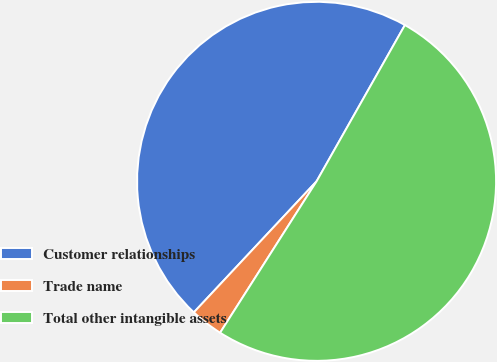Convert chart to OTSL. <chart><loc_0><loc_0><loc_500><loc_500><pie_chart><fcel>Customer relationships<fcel>Trade name<fcel>Total other intangible assets<nl><fcel>46.21%<fcel>2.95%<fcel>50.84%<nl></chart> 